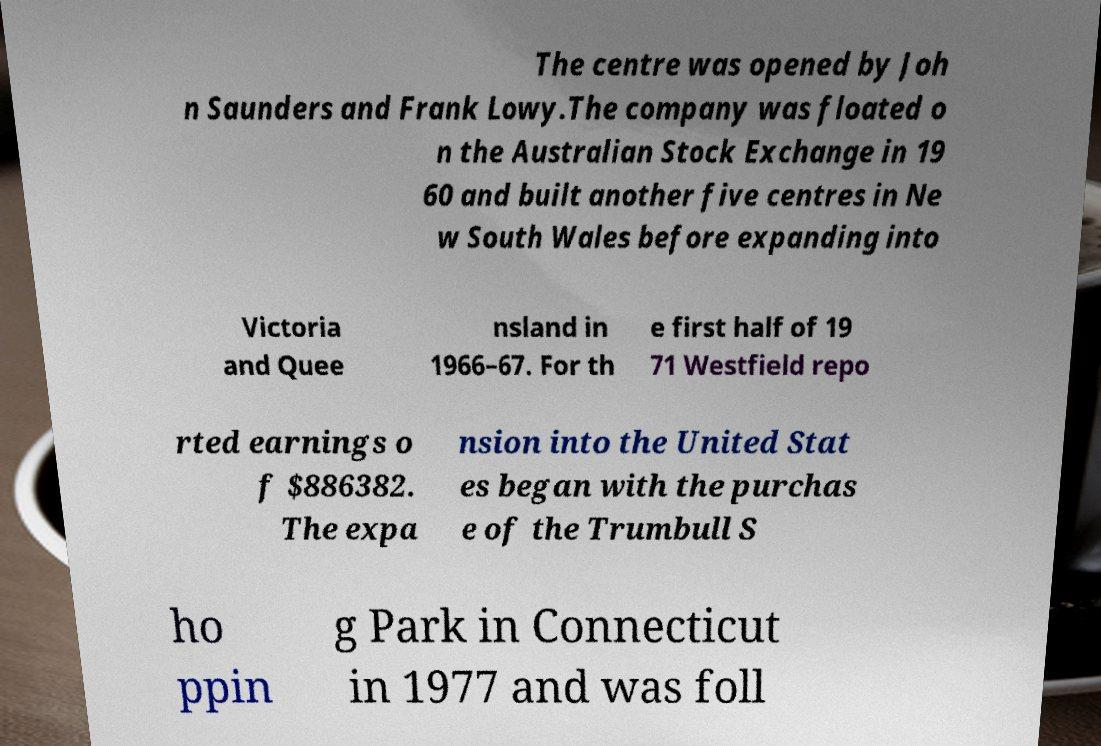Could you assist in decoding the text presented in this image and type it out clearly? The centre was opened by Joh n Saunders and Frank Lowy.The company was floated o n the Australian Stock Exchange in 19 60 and built another five centres in Ne w South Wales before expanding into Victoria and Quee nsland in 1966–67. For th e first half of 19 71 Westfield repo rted earnings o f $886382. The expa nsion into the United Stat es began with the purchas e of the Trumbull S ho ppin g Park in Connecticut in 1977 and was foll 